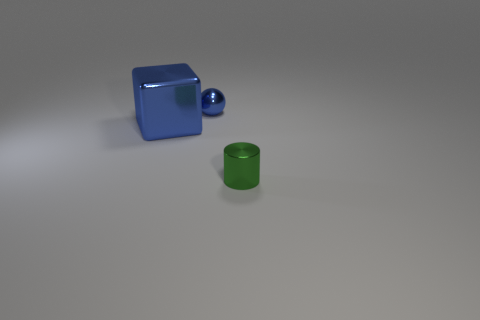Add 3 blue metallic balls. How many objects exist? 6 Subtract 1 cylinders. How many cylinders are left? 0 Subtract all gray cubes. How many yellow cylinders are left? 0 Subtract all tiny red balls. Subtract all balls. How many objects are left? 2 Add 3 green cylinders. How many green cylinders are left? 4 Add 1 tiny blue rubber things. How many tiny blue rubber things exist? 1 Subtract 0 cyan balls. How many objects are left? 3 Subtract all spheres. How many objects are left? 2 Subtract all red cylinders. Subtract all purple balls. How many cylinders are left? 1 